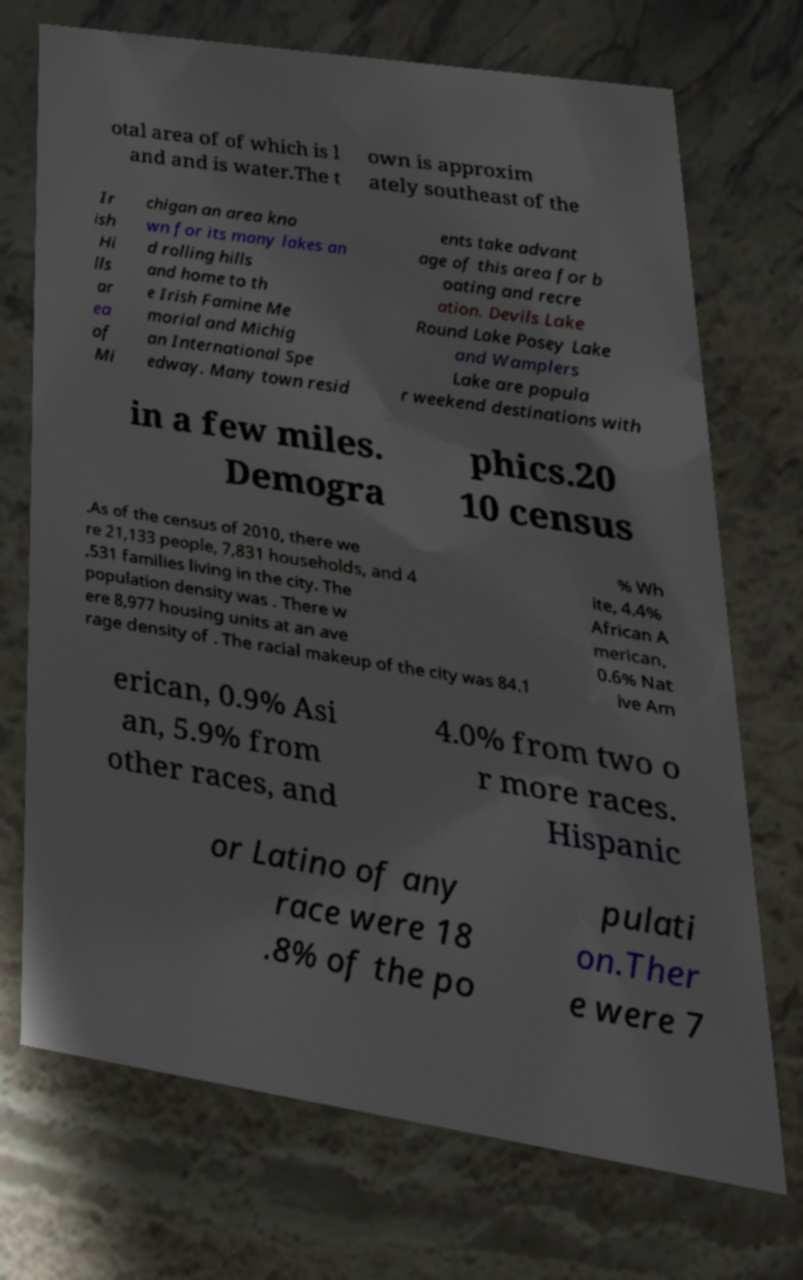Can you read and provide the text displayed in the image?This photo seems to have some interesting text. Can you extract and type it out for me? otal area of of which is l and and is water.The t own is approxim ately southeast of the Ir ish Hi lls ar ea of Mi chigan an area kno wn for its many lakes an d rolling hills and home to th e Irish Famine Me morial and Michig an International Spe edway. Many town resid ents take advant age of this area for b oating and recre ation. Devils Lake Round Lake Posey Lake and Wamplers Lake are popula r weekend destinations with in a few miles. Demogra phics.20 10 census .As of the census of 2010, there we re 21,133 people, 7,831 households, and 4 ,531 families living in the city. The population density was . There w ere 8,977 housing units at an ave rage density of . The racial makeup of the city was 84.1 % Wh ite, 4.4% African A merican, 0.6% Nat ive Am erican, 0.9% Asi an, 5.9% from other races, and 4.0% from two o r more races. Hispanic or Latino of any race were 18 .8% of the po pulati on.Ther e were 7 